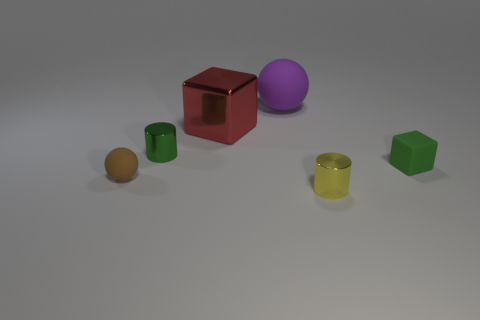What size is the metal object that is the same color as the matte cube?
Your response must be concise. Small. Do the ball that is behind the tiny green block and the big cube have the same color?
Offer a terse response. No. What is the color of the matte thing that is behind the brown matte ball and left of the green matte thing?
Your response must be concise. Purple. Are there any red blocks made of the same material as the small brown thing?
Provide a succinct answer. No. What size is the green block?
Provide a succinct answer. Small. How big is the thing that is right of the tiny metal cylinder that is in front of the green matte cube?
Offer a very short reply. Small. There is a small brown object that is the same shape as the purple matte object; what is its material?
Make the answer very short. Rubber. What number of small green cubes are there?
Offer a terse response. 1. There is a object that is in front of the small thing on the left side of the small metallic thing behind the matte block; what color is it?
Offer a very short reply. Yellow. Are there fewer big red shiny blocks than tiny gray metal blocks?
Your answer should be very brief. No. 